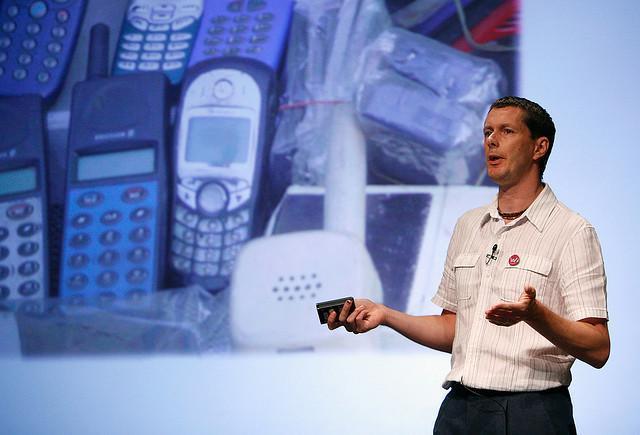What is the subject of the speech being given?
Select the accurate response from the four choices given to answer the question.
Options: Candy, cell phones, animal husbandry, womens rights. Cell phones. 